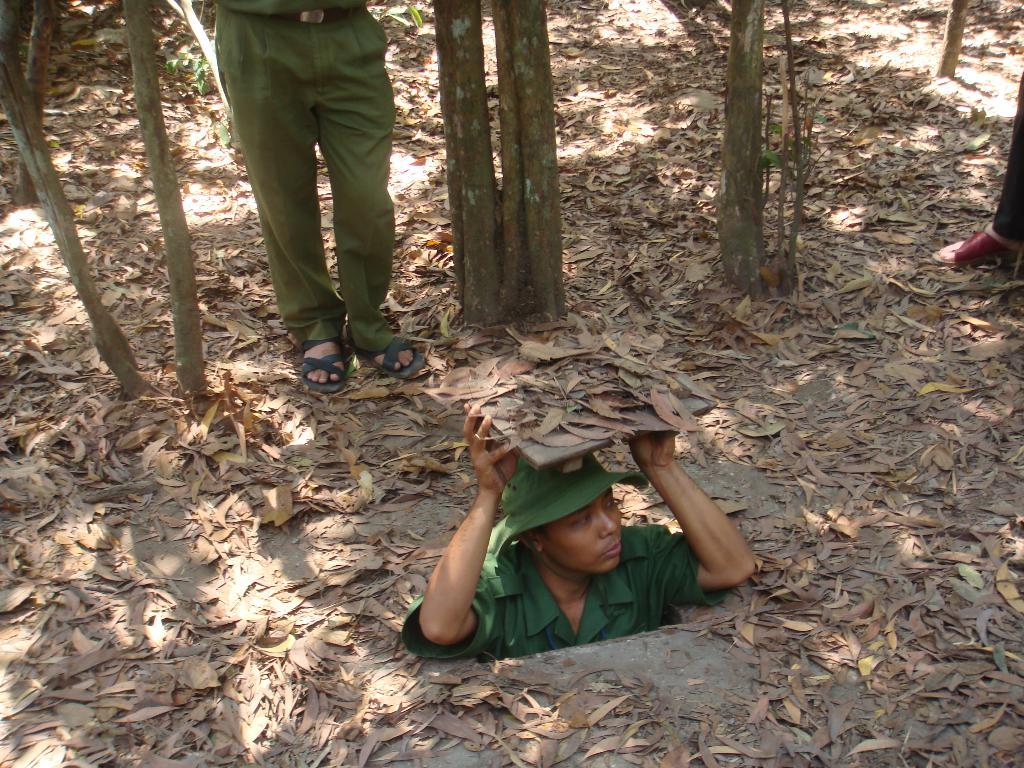What is the person in the image doing? The person is submerged in the image. What is the person holding in the image? The person is holding an object in the image. What type of natural environment can be seen in the image? There are trees and leaves on the ground in the image, indicating a natural environment. What part of the person's body is visible in the image? The legs of the person are visible in the image. How much money is the person holding in the image? There is no money visible in the image; the person is holding an object. Is there a baby present in the image? There is no baby present in the image; the main subject is a person who is submerged. 